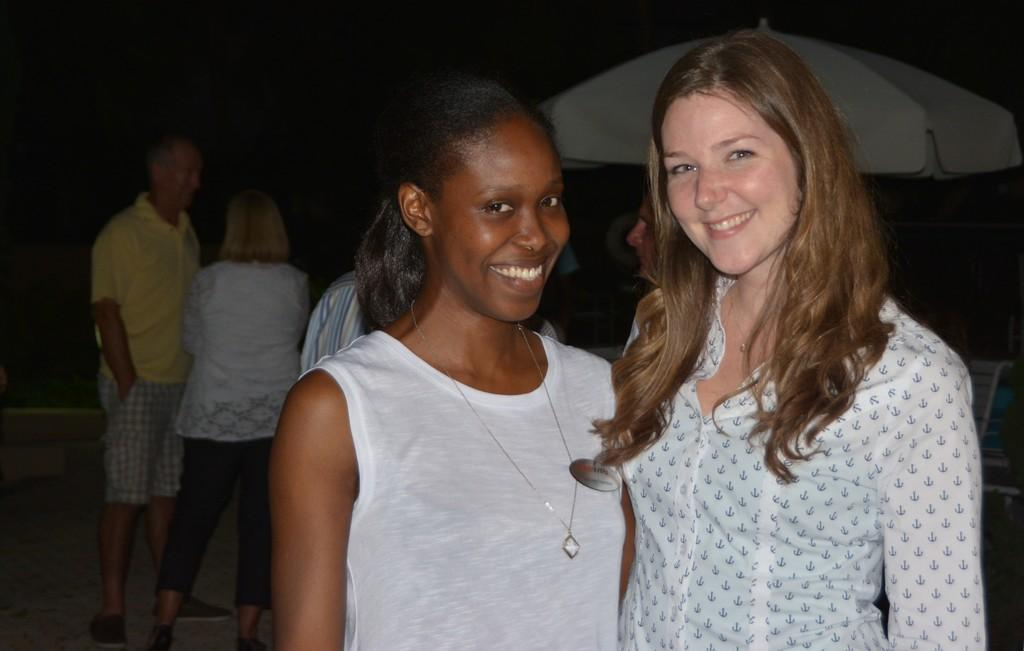What are the people in the image doing? The people in the image are standing on the ground. What type of furniture is present in the image? There is a chair in the image. What object can be seen providing shade or protection from the elements? There is an umbrella in the image. What type of operation is being performed on the rabbit in the image? There is no rabbit present in the image, so no operation is being performed. What sound can be heard coming from the chair in the image? There is no sound mentioned or depicted in the image, so it cannot be determined. 